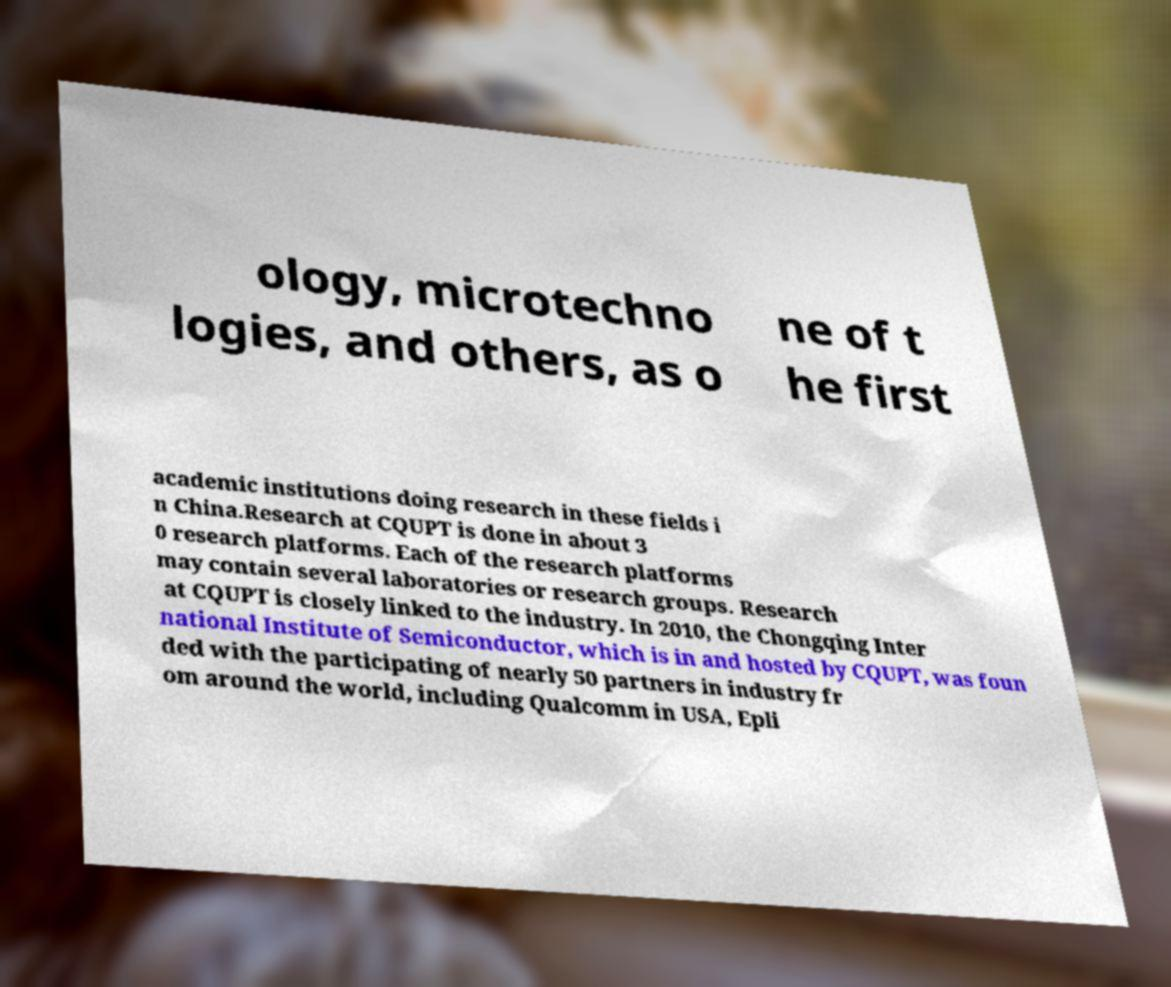Please read and relay the text visible in this image. What does it say? ology, microtechno logies, and others, as o ne of t he first academic institutions doing research in these fields i n China.Research at CQUPT is done in about 3 0 research platforms. Each of the research platforms may contain several laboratories or research groups. Research at CQUPT is closely linked to the industry. In 2010, the Chongqing Inter national Institute of Semiconductor, which is in and hosted by CQUPT, was foun ded with the participating of nearly 50 partners in industry fr om around the world, including Qualcomm in USA, Epli 